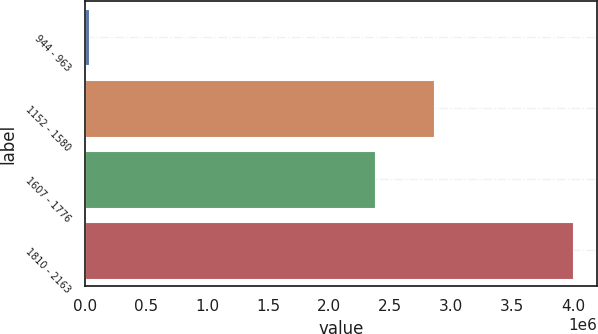<chart> <loc_0><loc_0><loc_500><loc_500><bar_chart><fcel>944 - 963<fcel>1152 - 1580<fcel>1607 - 1776<fcel>1810 - 2163<nl><fcel>31928<fcel>2.85668e+06<fcel>2.37128e+06<fcel>3.99693e+06<nl></chart> 